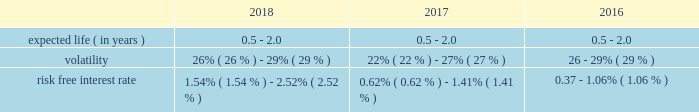Table of contents adobe inc .
Notes to consolidated financial statements ( continued ) stock options the 2003 plan allows us to grant options to all employees , including executive officers , outside consultants and non- employee directors .
This plan will continue until the earlier of ( i ) termination by the board or ( ii ) the date on which all of the shares available for issuance under the plan have been issued and restrictions on issued shares have lapsed .
Option vesting periods used in the past were generally four years and expire seven years from the effective date of grant .
We eliminated the use of stock option grants for all employees and non-employee directors but may choose to issue stock options in the future .
Performance share programs our 2018 , 2017 and 2016 performance share programs aim to help focus key employees on building stockholder value , provide significant award potential for achieving outstanding company performance and enhance the ability of the company to attract and retain highly talented and competent individuals .
The executive compensation committee of our board of directors approves the terms of each of our performance share programs , including the award calculation methodology , under the terms of our 2003 plan .
Shares may be earned based on the achievement of an objective relative total stockholder return measured over a three-year performance period .
Performance share awards will be awarded and fully vest upon the later of the executive compensation committee's certification of the level of achievement or the three-year anniversary of each grant .
Program participants generally have the ability to receive up to 200% ( 200 % ) of the target number of shares originally granted .
On january 24 , 2018 , the executive compensation committee approved the 2018 performance share program , the terms of which are similar to prior year performance share programs as discussed above .
As of november 30 , 2018 , the shares awarded under our 2018 , 2017 and 2016 performance share programs are yet to be achieved .
Issuance of shares upon exercise of stock options , vesting of restricted stock units and performance shares , and purchases of shares under the espp , we will issue treasury stock .
If treasury stock is not available , common stock will be issued .
In order to minimize the impact of on-going dilution from exercises of stock options and vesting of restricted stock units and performance shares , we instituted a stock repurchase program .
See note 12 for information regarding our stock repurchase programs .
Valuation of stock-based compensation stock-based compensation cost is measured at the grant date based on the fair value of the award .
Our performance share awards are valued using a monte carlo simulation model .
The fair value of the awards are fixed at grant date and amortized over the longer of the remaining performance or service period .
We use the black-scholes option pricing model to determine the fair value of espp shares .
The determination of the fair value of stock-based payment awards on the date of grant using an option pricing model is affected by our stock price as well as assumptions regarding a number of complex and subjective variables .
These variables include our expected stock price volatility over the expected term of the awards , actual and projected employee stock option exercise behaviors , a risk-free interest rate and any expected dividends .
The expected term of espp shares is the average of the remaining purchase periods under each offering period .
The assumptions used to value employee stock purchase rights were as follows: .

What is the average volatility used to value employee stock purchase rights in 2018? 
Computations: ((26% + 29%) / 2)
Answer: 0.275. 